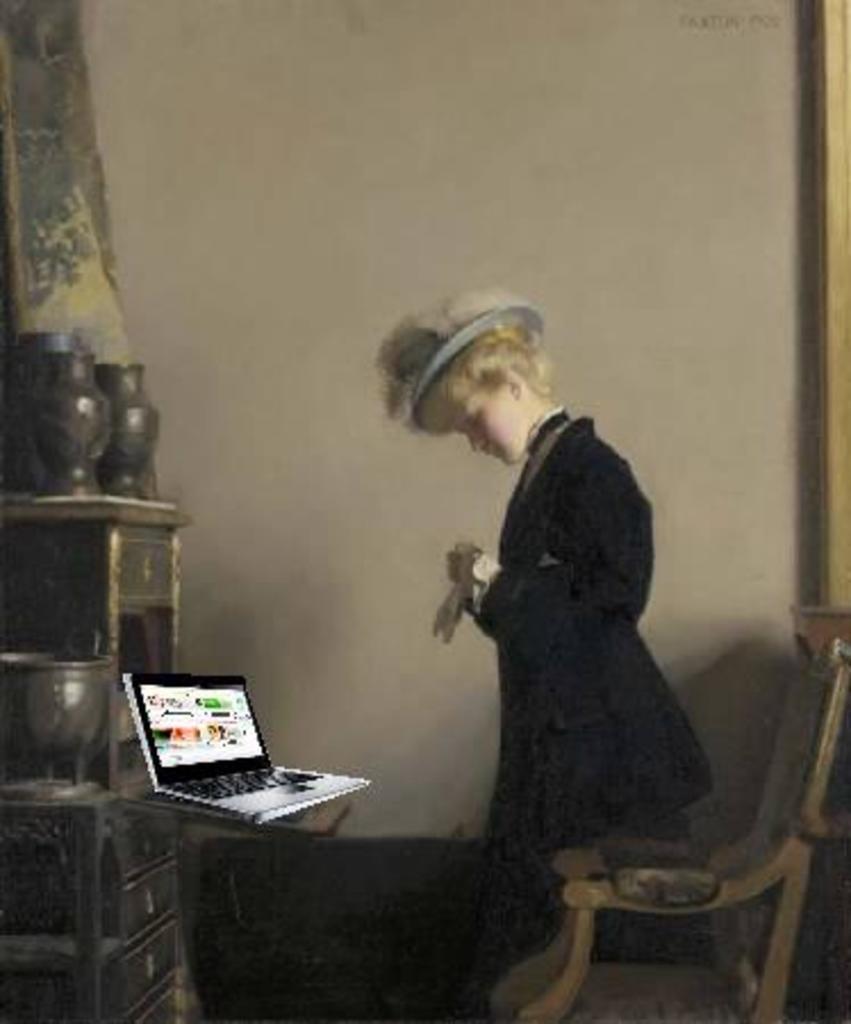Could you give a brief overview of what you see in this image? In this image, we can see human in suit. There is a hat on his head. On right side, there is a chair. Left side, cupboards, few items are placed on it and laptop. The backside, there is a wall. 